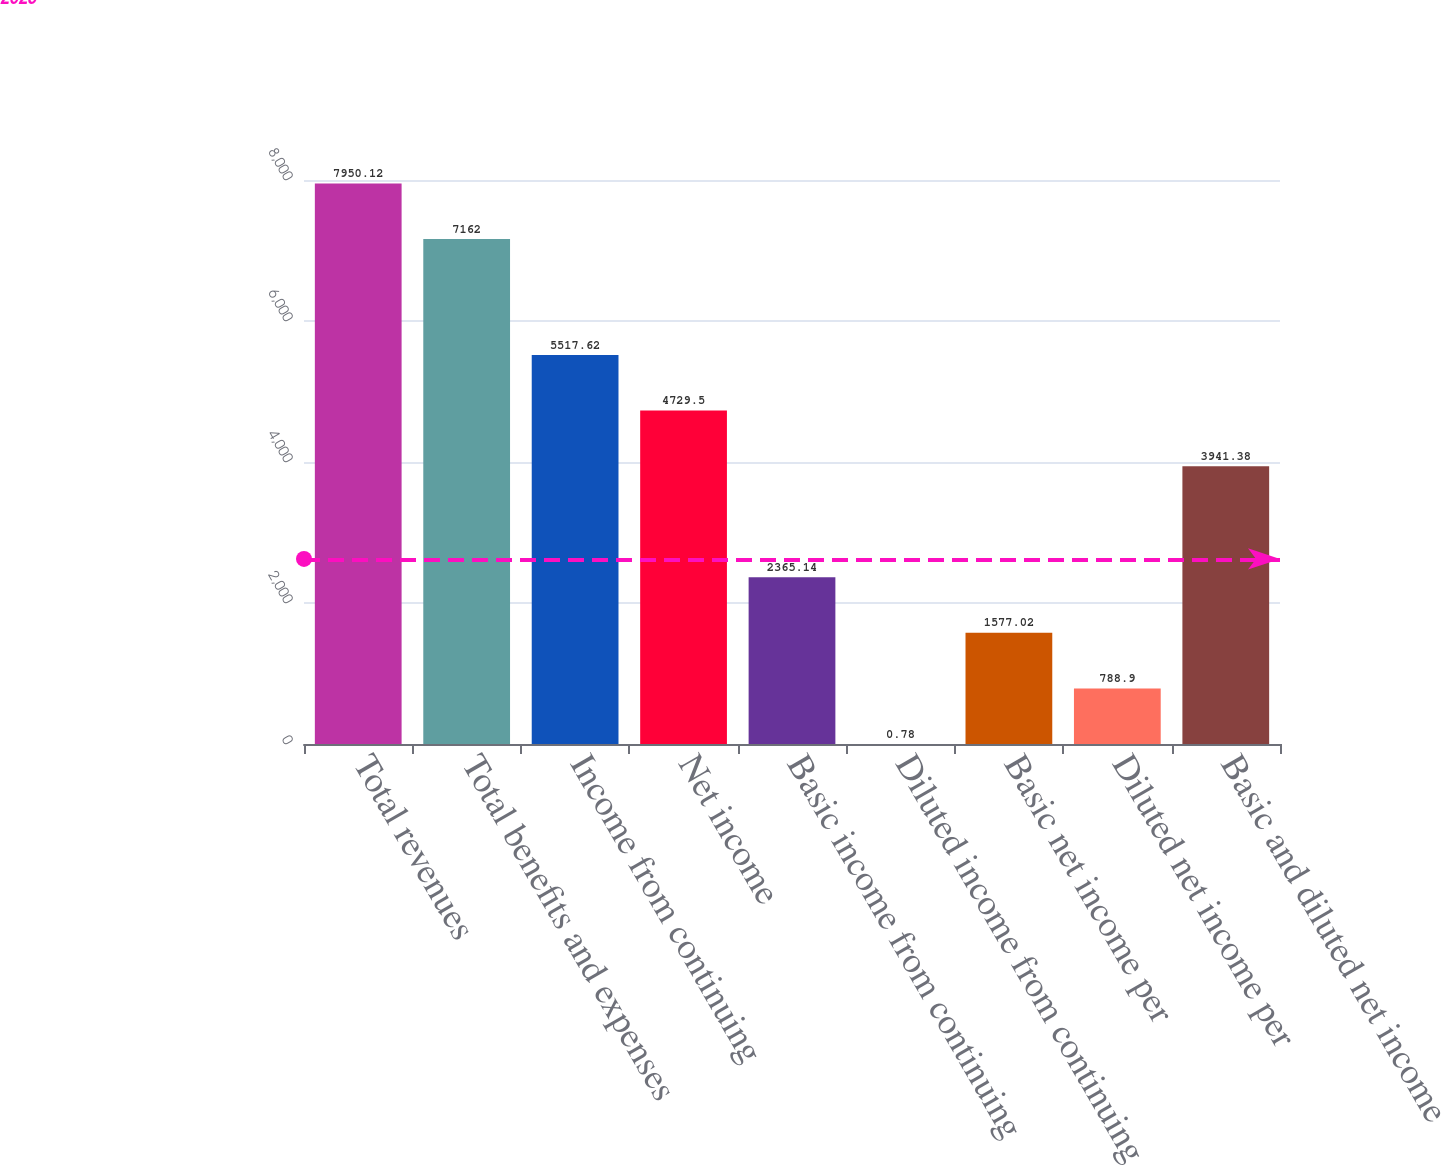<chart> <loc_0><loc_0><loc_500><loc_500><bar_chart><fcel>Total revenues<fcel>Total benefits and expenses<fcel>Income from continuing<fcel>Net income<fcel>Basic income from continuing<fcel>Diluted income from continuing<fcel>Basic net income per<fcel>Diluted net income per<fcel>Basic and diluted net income<nl><fcel>7950.12<fcel>7162<fcel>5517.62<fcel>4729.5<fcel>2365.14<fcel>0.78<fcel>1577.02<fcel>788.9<fcel>3941.38<nl></chart> 